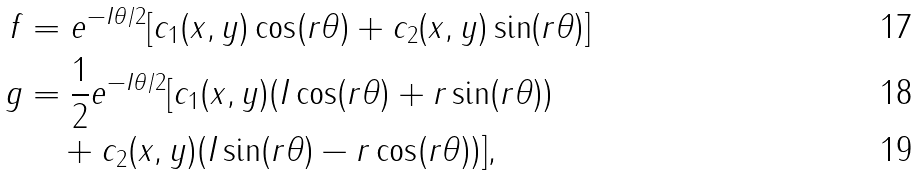<formula> <loc_0><loc_0><loc_500><loc_500>f & = e ^ { - I \theta / 2 } [ c _ { 1 } ( x , y ) \cos ( r \theta ) + c _ { 2 } ( x , y ) \sin ( r \theta ) ] \\ g & = \frac { 1 } { 2 } e ^ { - I \theta / 2 } [ c _ { 1 } ( x , y ) ( I \cos ( r \theta ) + r \sin ( r \theta ) ) \\ & \quad + c _ { 2 } ( x , y ) ( I \sin ( r \theta ) - r \cos ( r \theta ) ) ] ,</formula> 